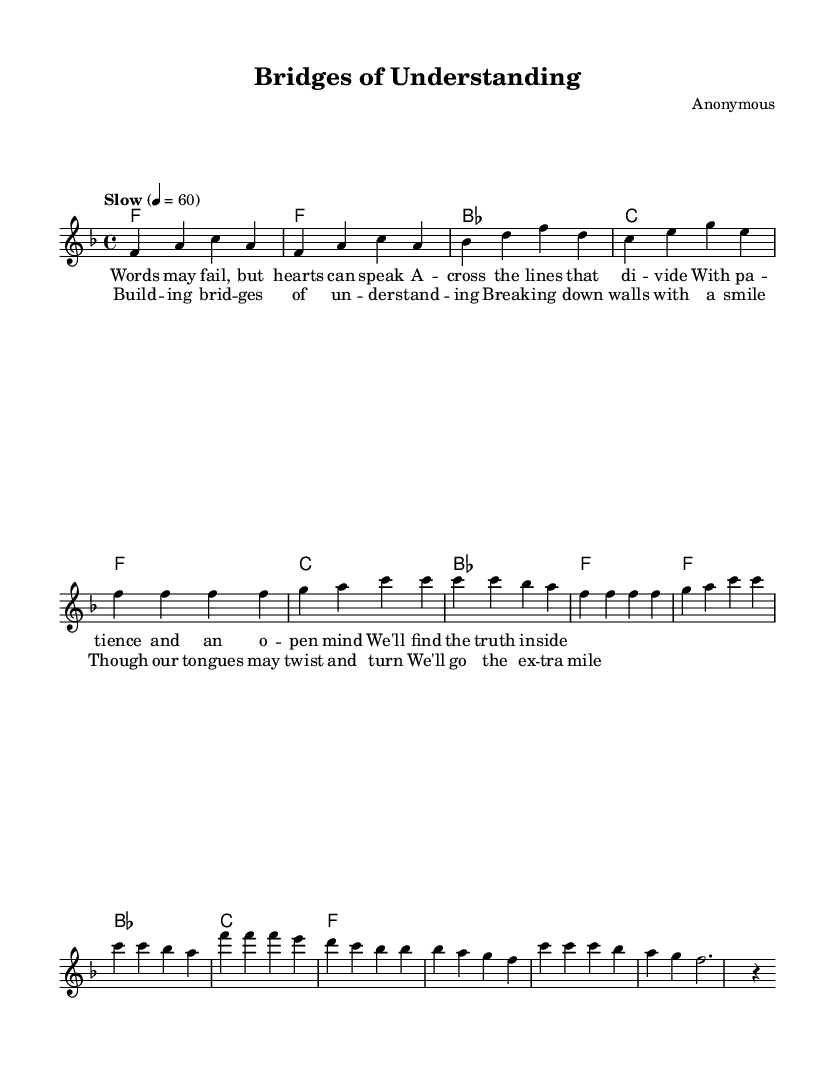What is the key signature of this music? The key signature is F major, which has one flat (B flat).
Answer: F major What is the time signature of this piece? The time signature indicated is four beats per measure, typically written as 4/4.
Answer: 4/4 What is the tempo marking for this composition? The tempo marking suggests a slow pace, setting the beats at 60 per minute.
Answer: Slow 4 = 60 How many measures are in the chorus section? By counting the measures in the chorus part, we find that there are four measures.
Answer: 4 What is the primary theme expressed in the lyrics? The lyrics convey a message about overcoming communication barriers and fostering understanding.
Answer: Understanding Which chord appears most frequently in the verse? The chord that appears most frequently in the verse is F major.
Answer: F What type of music is this sheet representing? This sheet represents a Rhythm and Blues style ballad focused on themes of connection and communication.
Answer: Rhythm and Blues 